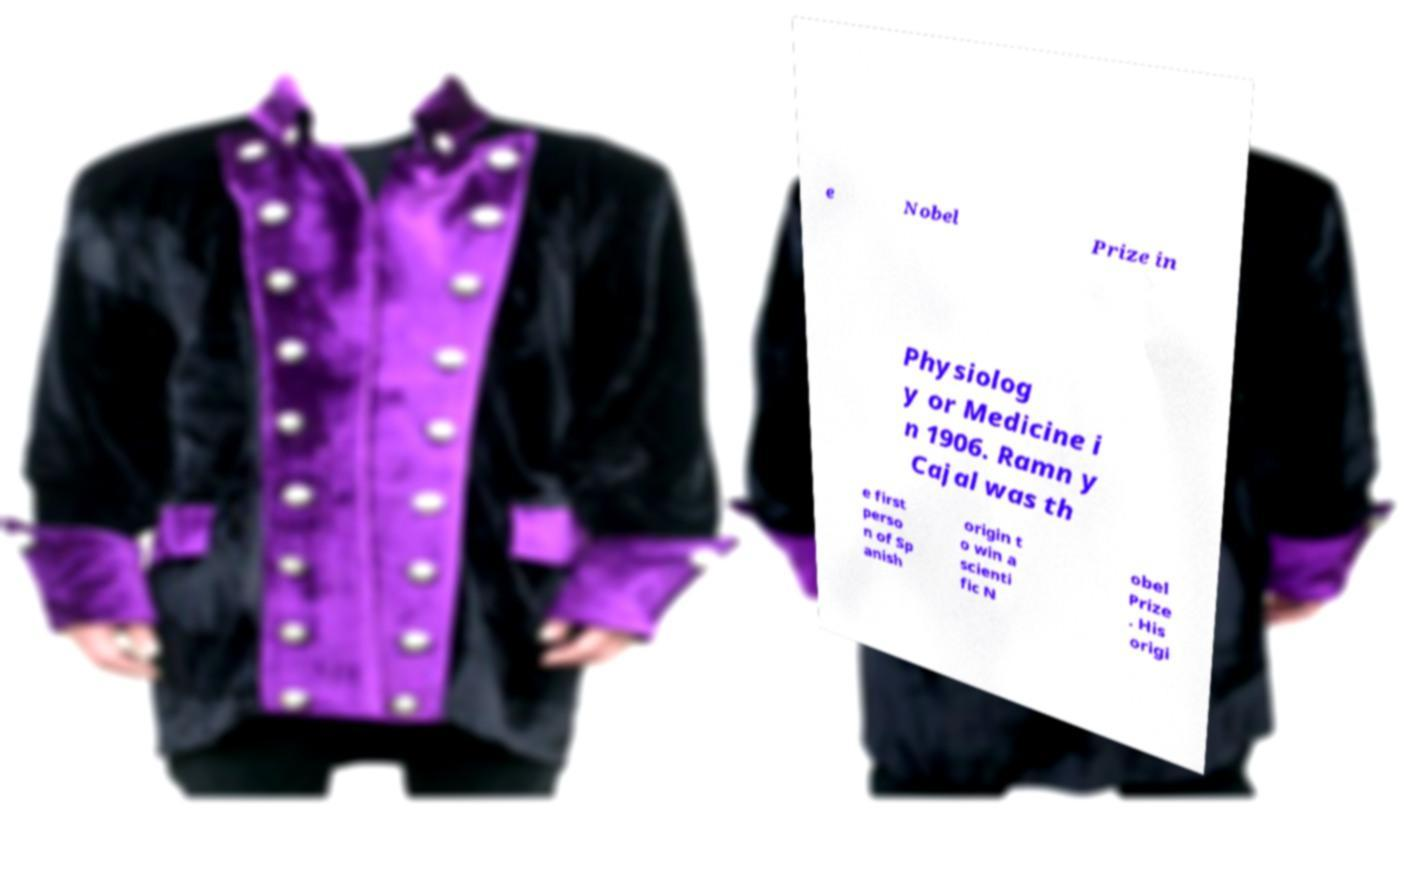Can you accurately transcribe the text from the provided image for me? e Nobel Prize in Physiolog y or Medicine i n 1906. Ramn y Cajal was th e first perso n of Sp anish origin t o win a scienti fic N obel Prize . His origi 